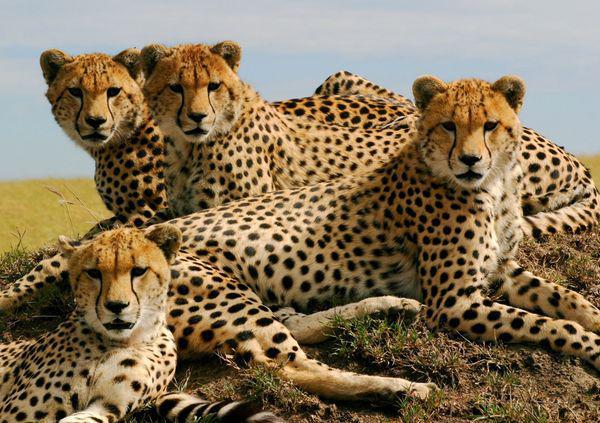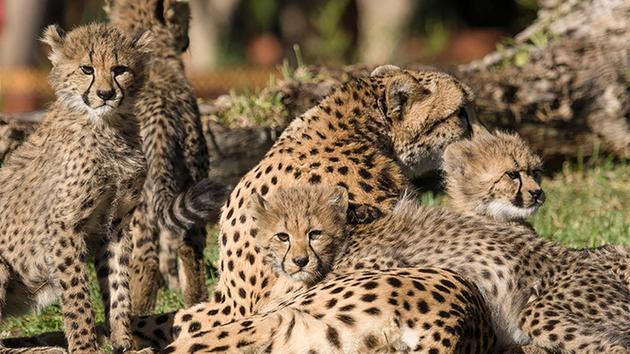The first image is the image on the left, the second image is the image on the right. Considering the images on both sides, is "There are no more than three animals in one of the images." valid? Answer yes or no. No. 